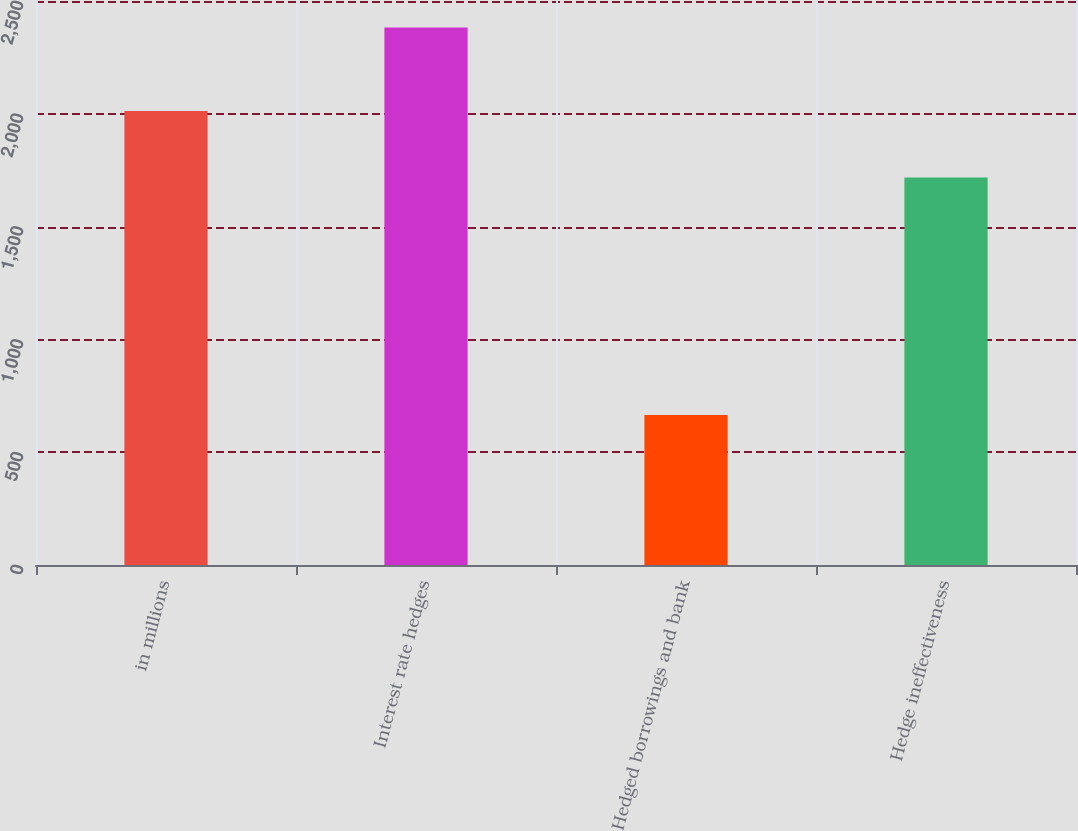Convert chart. <chart><loc_0><loc_0><loc_500><loc_500><bar_chart><fcel>in millions<fcel>Interest rate hedges<fcel>Hedged borrowings and bank<fcel>Hedge ineffectiveness<nl><fcel>2012<fcel>2383<fcel>665<fcel>1718<nl></chart> 